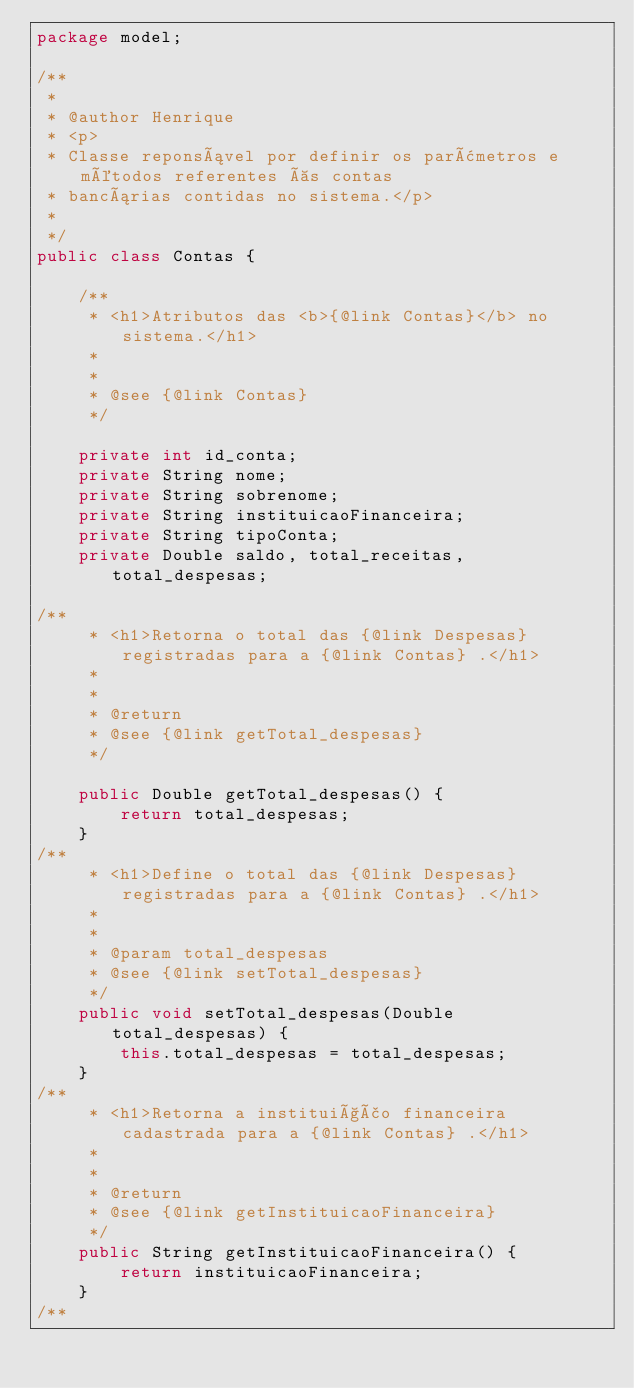Convert code to text. <code><loc_0><loc_0><loc_500><loc_500><_Java_>package model;

/**
 *
 * @author Henrique
 * <p>
 * Classe reponsável por definir os parâmetros e métodos referentes às contas
 * bancárias contidas no sistema.</p>
 *
 */
public class Contas {
    
    /**
     * <h1>Atributos das <b>{@link Contas}</b> no sistema.</h1>
     *
     *
     * @see {@link Contas}
     */
    
    private int id_conta;
    private String nome;
    private String sobrenome;
    private String instituicaoFinanceira;
    private String tipoConta;
    private Double saldo, total_receitas, total_despesas;

/**
     * <h1>Retorna o total das {@link Despesas} registradas para a {@link Contas} .</h1>
     *
     *
     * @return 
     * @see {@link getTotal_despesas}
     */
    
    public Double getTotal_despesas() {
        return total_despesas;
    }
/**
     * <h1>Define o total das {@link Despesas} registradas para a {@link Contas} .</h1>
     *
     * 
     * @param total_despesas
     * @see {@link setTotal_despesas}
     */
    public void setTotal_despesas(Double total_despesas) {
        this.total_despesas = total_despesas;
    }
/**
     * <h1>Retorna a instituição financeira cadastrada para a {@link Contas} .</h1>
     *
     *
     * @return 
     * @see {@link getInstituicaoFinanceira}
     */
    public String getInstituicaoFinanceira() {
        return instituicaoFinanceira;
    }
/**</code> 